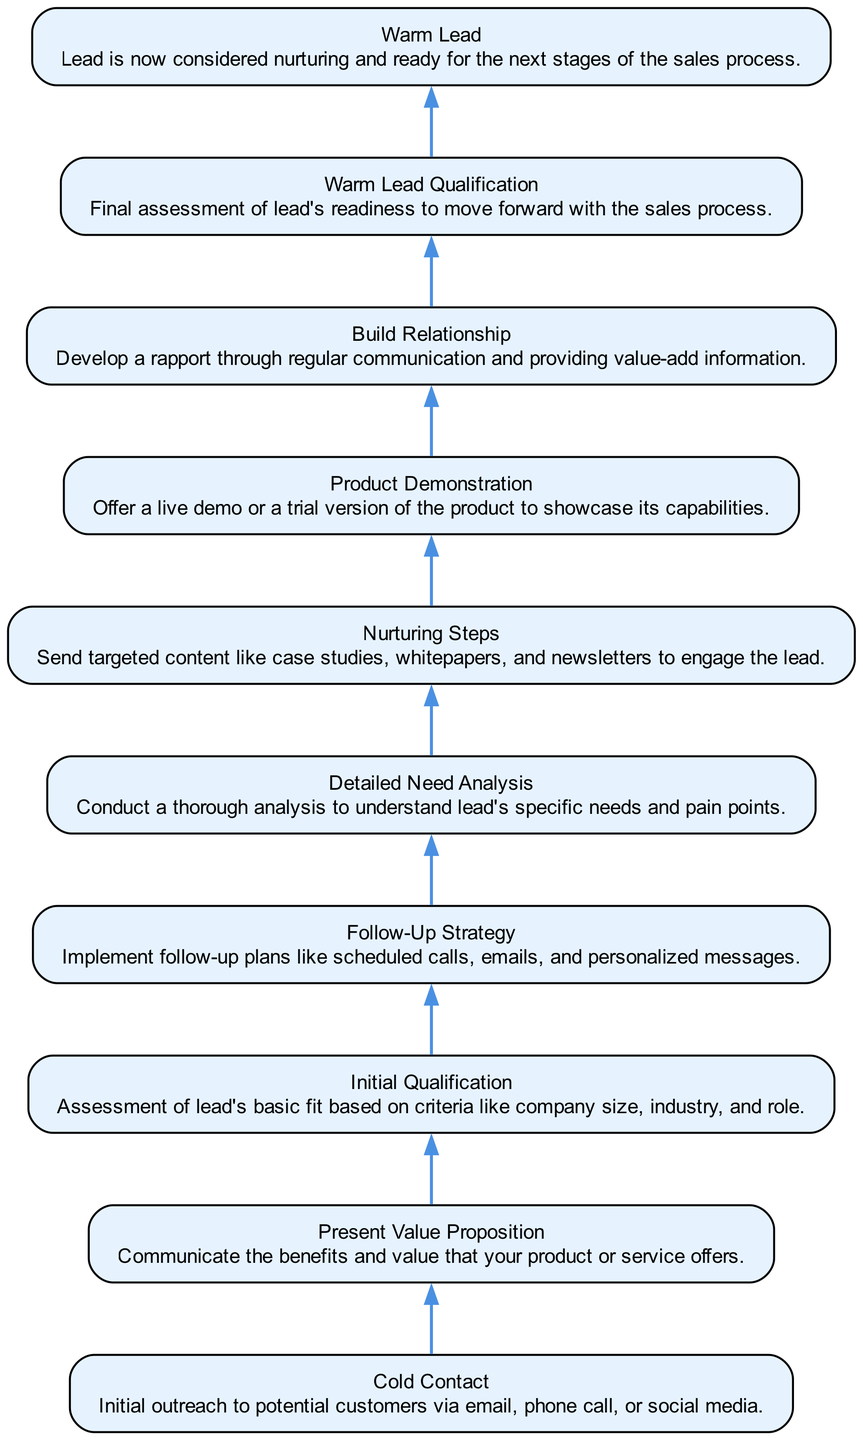What is the first stage in the lead qualification process? The first stage in the lead qualification process shown at the bottom of the diagram is "Cold Contact", which represents the initial outreach to potential customers.
Answer: Cold Contact How many nodes are in the diagram? Counting all the stages from the bottom to the top, there are ten nodes displayed in this flowchart that represent different stages of the lead qualification process.
Answer: 10 What is the relationship between "Initial Qualification" and "Follow-Up Strategy"? "Initial Qualification" precedes "Follow-Up Strategy" in the diagram, indicating that once the initial qualification of the lead has been completed, the next step is to implement follow-up strategies.
Answer: Follow-Up Strategy What is indicated by the node "Warm Lead"? The node "Warm Lead" indicates that the lead has been nurtured and is now ready for the next stages of the sales process, implying that the lead is qualified further for sales.
Answer: Warm Lead Which step involves sending targeted content? The step that involves sending targeted content is "Nurturing Steps", where targeted materials like case studies and newsletters are shared to engage the lead further.
Answer: Nurturing Steps What precedes the "Product Demonstration" stage? The "Detailed Need Analysis" stage comes before the "Product Demonstration", implying that an understanding of the lead's specific needs must be established prior to demonstrating the product.
Answer: Detailed Need Analysis How does the lead move from "Nurturing Steps" to "Warm Lead Qualification"? The diagram shows that after completing "Nurturing Steps", the lead proceeds to "Warm Lead Qualification", suggesting that nurturing prepares and qualifies the lead for a final assessment.
Answer: Warm Lead Qualification What is the overall flow direction of the diagram? The overall flow direction of the diagram is from bottom to top, indicating the progression of leads as they are qualified through various stages until they reach a warm lead status.
Answer: Bottom to top 